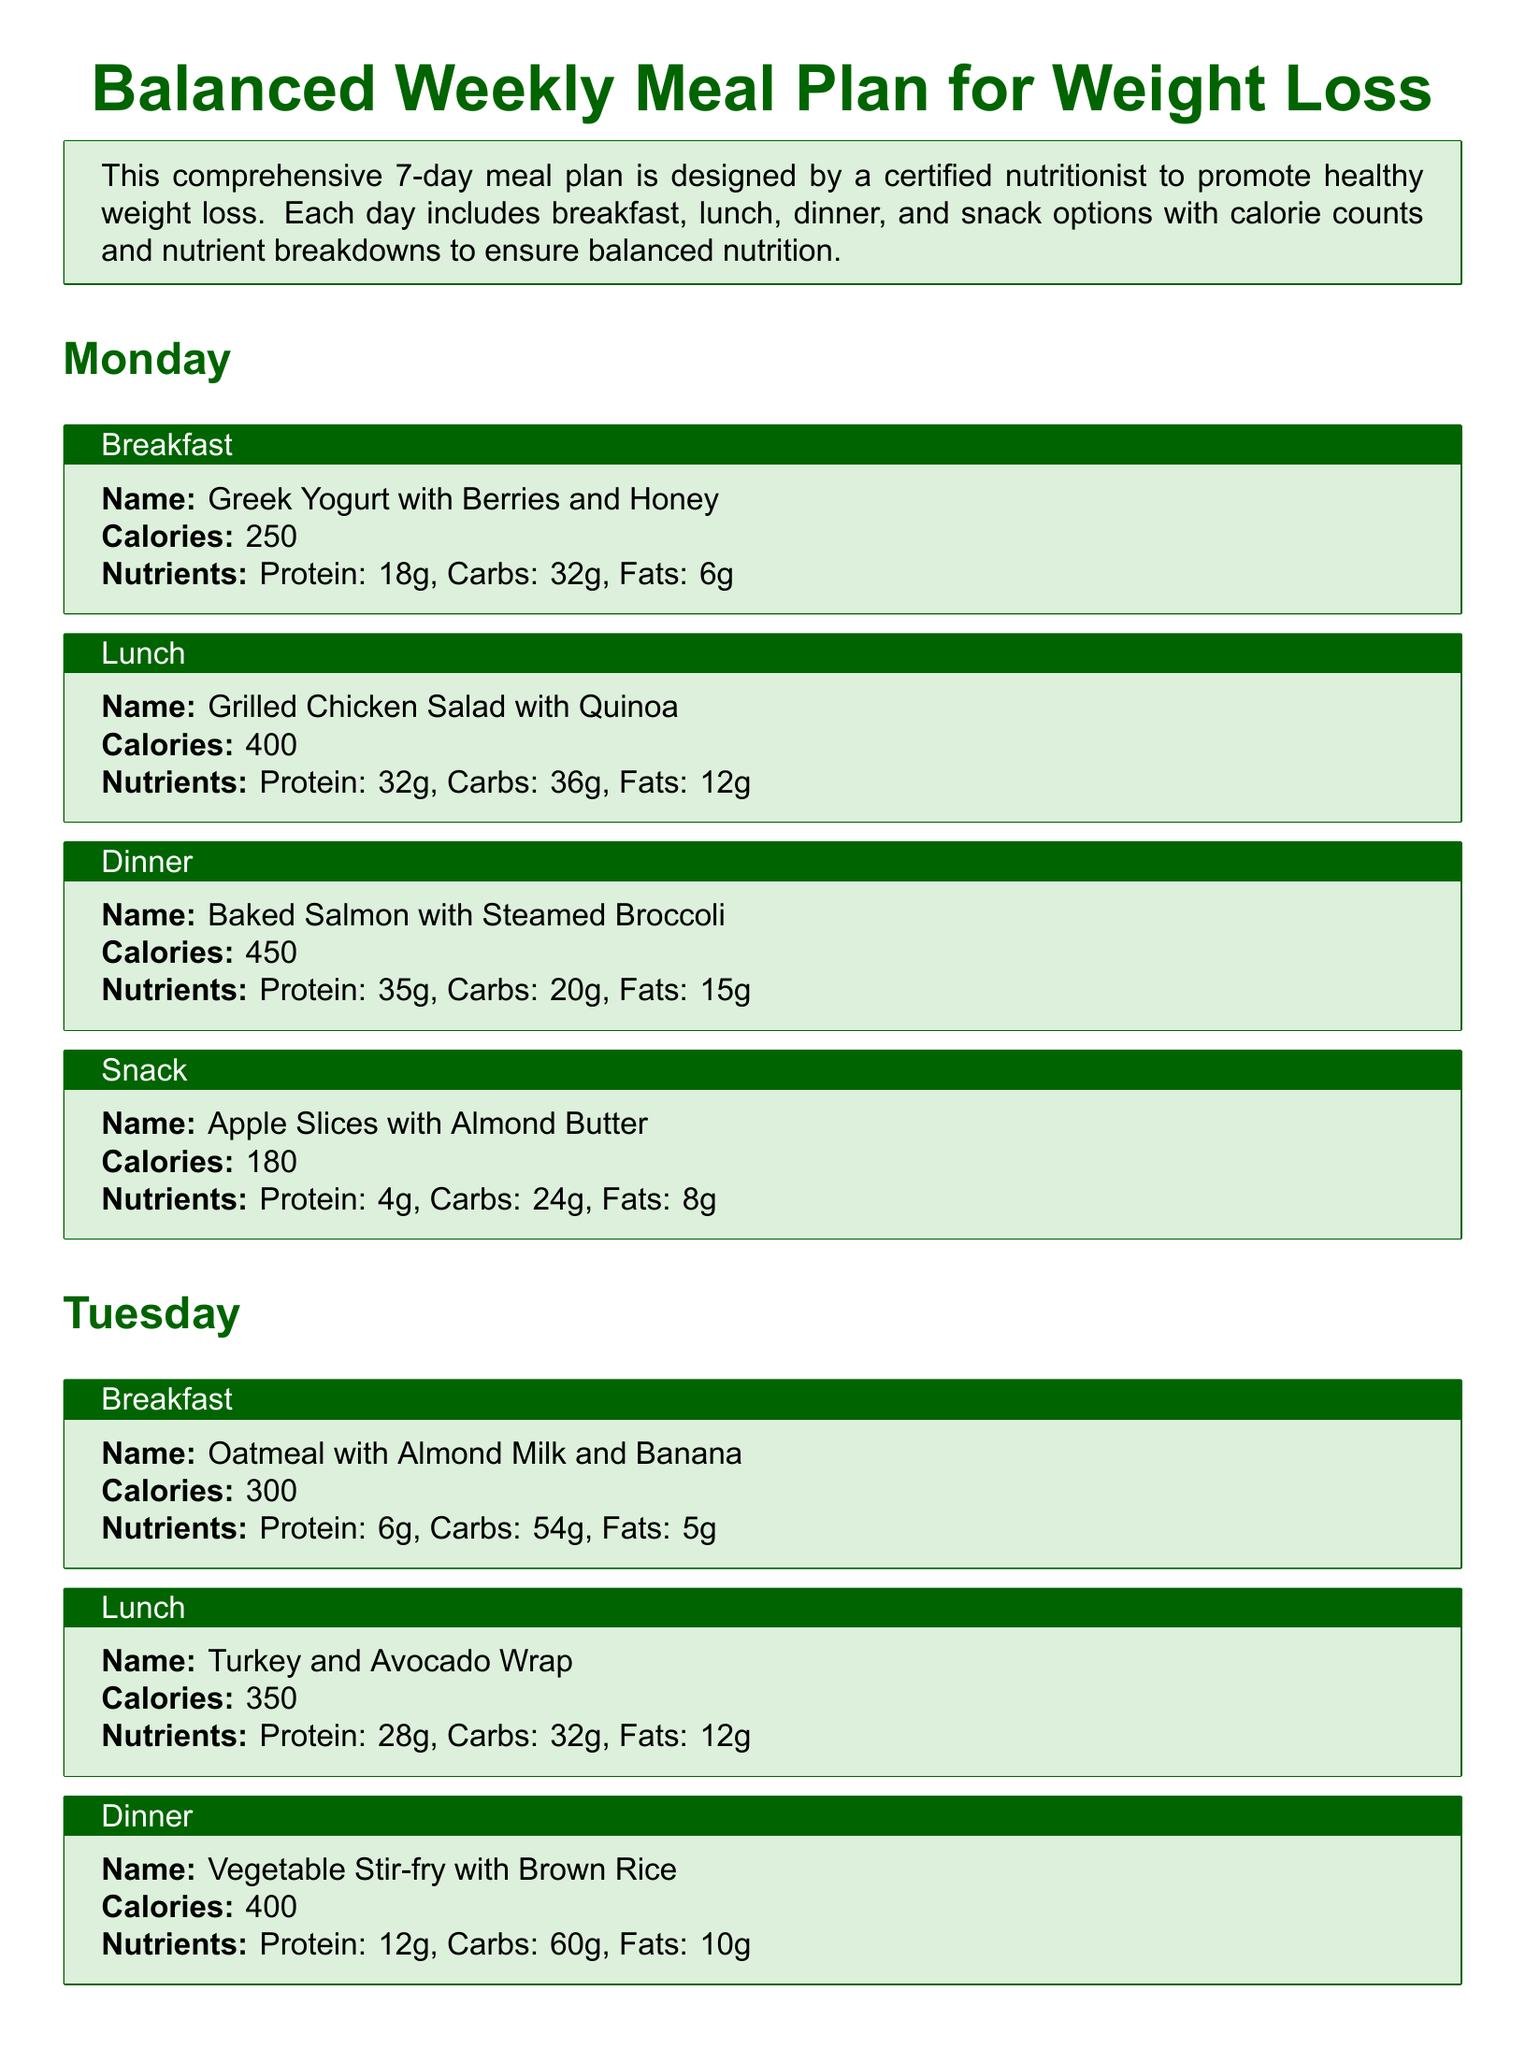What is the total calorie count for Monday's meals? The total calorie count for Monday's meals is 250 + 400 + 450 + 180 = 1280.
Answer: 1280 What is the protein content in Tuesday's lunch? The protein content in Tuesday's lunch, which is a Turkey and Avocado Wrap, is 28g.
Answer: 28g How many grams of carbs are in Wednesday's dinner? The carbs in Wednesday's dinner, Grilled Shrimp Tacos with Salsa, amount to 45g.
Answer: 45g What is the calorie count of the snack on Monday? The calorie count for the snack on Monday, Apple Slices with Almond Butter, is 180 calories.
Answer: 180 How many different types of meals are provided each day? Each day includes breakfast, lunch, dinner, and a snack, totaling four types of meals.
Answer: Four What is the total calories for the meal plan over a week? The total calories for the meal plan over a week equals the sum of all daily calorie counts, leading to a result of 1280 (Mon) + 1300 (Tue) + 1140 (Wed) + ... etc., which requires individual calculation for all seven days.
Answer: Total requires calculation Which meal type is served as a snack on Tuesday? On Tuesday, the snack is Greek Yogurt with Honey.
Answer: Greek Yogurt with Honey What is the main protein source in the Wednesday lunch? The main protein source in Wednesday's lunch, Chickpea and Vegetable Salad, is chickpeas.
Answer: Chickpeas What nutrient is highest in Monday's dinner? The nutrient highest in Monday's dinner, Baked Salmon with Steamed Broccoli, is protein, at 35g.
Answer: Protein 